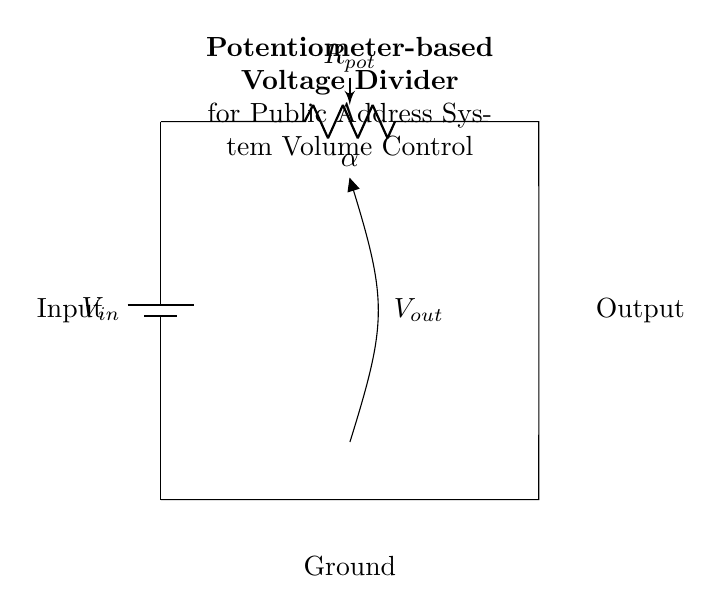What is the input voltage of this circuit? The circuit indicates an input represented by \( V_{in} \) which is connected to the positive terminal of the battery. The specific value is not given in the diagram but it is denoted by the symbol for input voltage.
Answer: Vin What component is used for volume control? The circuit uses a potentiometer labeled as \( R_{pot} \), which is adjustable and serves to vary the voltage output depending on its resistance setting.
Answer: Potentiometer What is the output voltage labeled as in this circuit? The output voltage is represented as \( V_{out} \), shown directly connected to the potentiometer's middle terminal, indicating the voltage that can be adjusted and taken out for further use.
Answer: Vout How many terminals does the potentiometer have? A typical potentiometer has three terminals: one connected to the input voltage, one to ground, and one as the adjustable output. The diagram suggests the same configuration.
Answer: Three What connects the output of the potentiometer to the ground? The circuit shows a direct short from the output terminal to the ground, allowing the current to flow back to the ground, which completes the circuit.
Answer: Short What would happen if \( R_{pot} \) is set to its minimum resistance? If \( R_{pot} \) is minimized, the output voltage \( V_{out} \) will drop to zero since it directly connects to ground, resulting in no sound output in the public address system.
Answer: Zero 